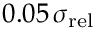Convert formula to latex. <formula><loc_0><loc_0><loc_500><loc_500>0 . 0 5 \, \sigma _ { r e l }</formula> 